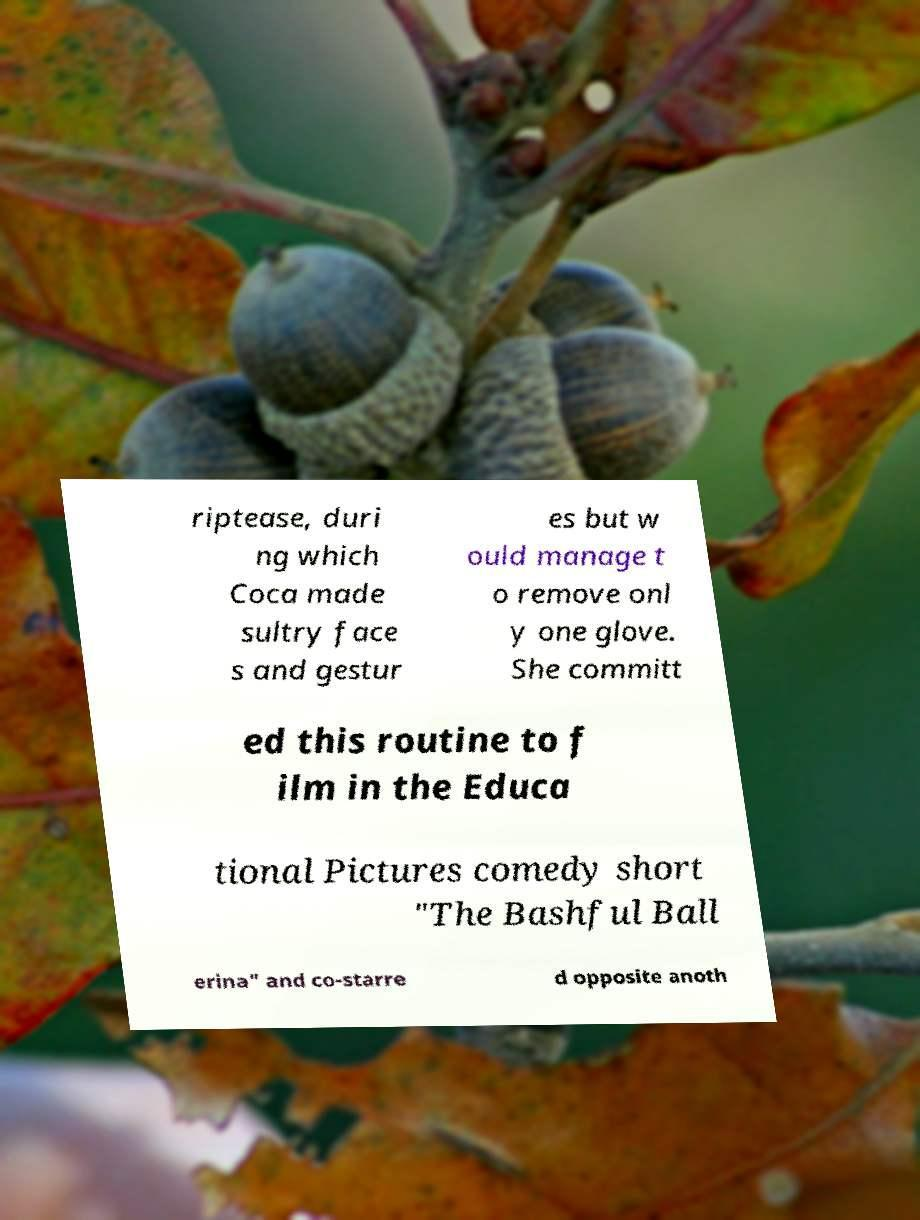Can you accurately transcribe the text from the provided image for me? riptease, duri ng which Coca made sultry face s and gestur es but w ould manage t o remove onl y one glove. She committ ed this routine to f ilm in the Educa tional Pictures comedy short "The Bashful Ball erina" and co-starre d opposite anoth 